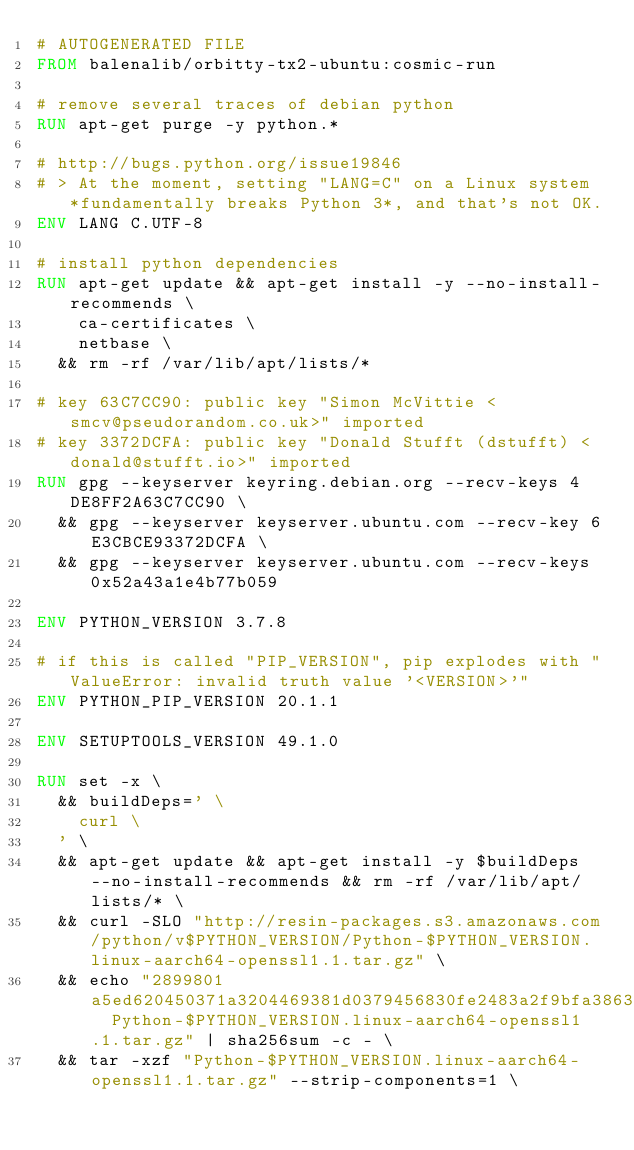<code> <loc_0><loc_0><loc_500><loc_500><_Dockerfile_># AUTOGENERATED FILE
FROM balenalib/orbitty-tx2-ubuntu:cosmic-run

# remove several traces of debian python
RUN apt-get purge -y python.*

# http://bugs.python.org/issue19846
# > At the moment, setting "LANG=C" on a Linux system *fundamentally breaks Python 3*, and that's not OK.
ENV LANG C.UTF-8

# install python dependencies
RUN apt-get update && apt-get install -y --no-install-recommends \
		ca-certificates \
		netbase \
	&& rm -rf /var/lib/apt/lists/*

# key 63C7CC90: public key "Simon McVittie <smcv@pseudorandom.co.uk>" imported
# key 3372DCFA: public key "Donald Stufft (dstufft) <donald@stufft.io>" imported
RUN gpg --keyserver keyring.debian.org --recv-keys 4DE8FF2A63C7CC90 \
	&& gpg --keyserver keyserver.ubuntu.com --recv-key 6E3CBCE93372DCFA \
	&& gpg --keyserver keyserver.ubuntu.com --recv-keys 0x52a43a1e4b77b059

ENV PYTHON_VERSION 3.7.8

# if this is called "PIP_VERSION", pip explodes with "ValueError: invalid truth value '<VERSION>'"
ENV PYTHON_PIP_VERSION 20.1.1

ENV SETUPTOOLS_VERSION 49.1.0

RUN set -x \
	&& buildDeps=' \
		curl \
	' \
	&& apt-get update && apt-get install -y $buildDeps --no-install-recommends && rm -rf /var/lib/apt/lists/* \
	&& curl -SLO "http://resin-packages.s3.amazonaws.com/python/v$PYTHON_VERSION/Python-$PYTHON_VERSION.linux-aarch64-openssl1.1.tar.gz" \
	&& echo "2899801a5ed620450371a3204469381d0379456830fe2483a2f9bfa38633b845  Python-$PYTHON_VERSION.linux-aarch64-openssl1.1.tar.gz" | sha256sum -c - \
	&& tar -xzf "Python-$PYTHON_VERSION.linux-aarch64-openssl1.1.tar.gz" --strip-components=1 \</code> 